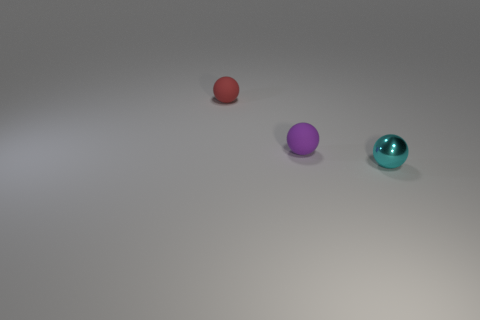Subtract all red rubber spheres. How many spheres are left? 2 Subtract 1 spheres. How many spheres are left? 2 Subtract all green cylinders. How many purple spheres are left? 1 Subtract all small purple balls. Subtract all purple matte things. How many objects are left? 1 Add 3 red matte objects. How many red matte objects are left? 4 Add 1 small cyan matte cubes. How many small cyan matte cubes exist? 1 Add 2 red things. How many objects exist? 5 Subtract all purple balls. How many balls are left? 2 Subtract 0 yellow cylinders. How many objects are left? 3 Subtract all red balls. Subtract all purple cylinders. How many balls are left? 2 